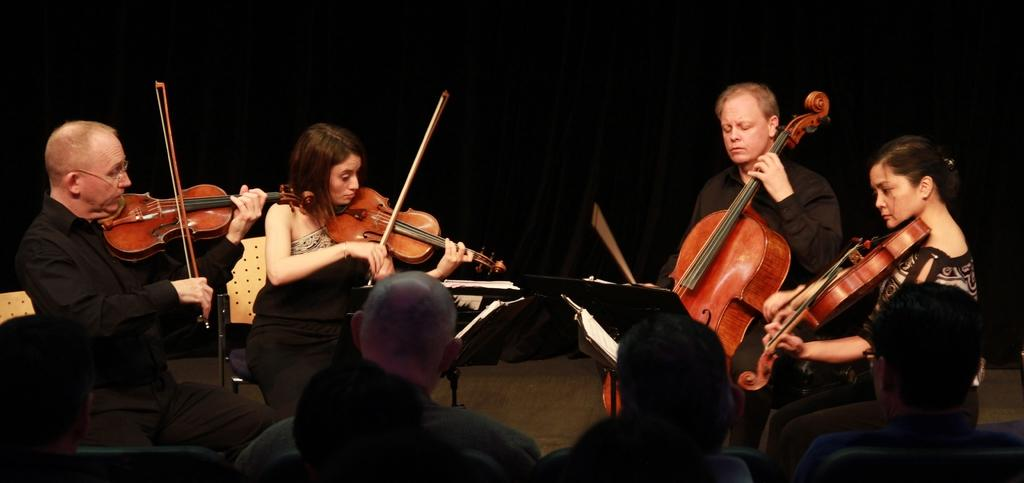Who is present in the image? There are people in the image. What are the people doing in the image? The people are sitting on chairs and playing musical instruments. What type of books can be seen on the fairies' laps in the image? There are no fairies or books present in the image; it features people playing musical instruments while sitting on chairs. 